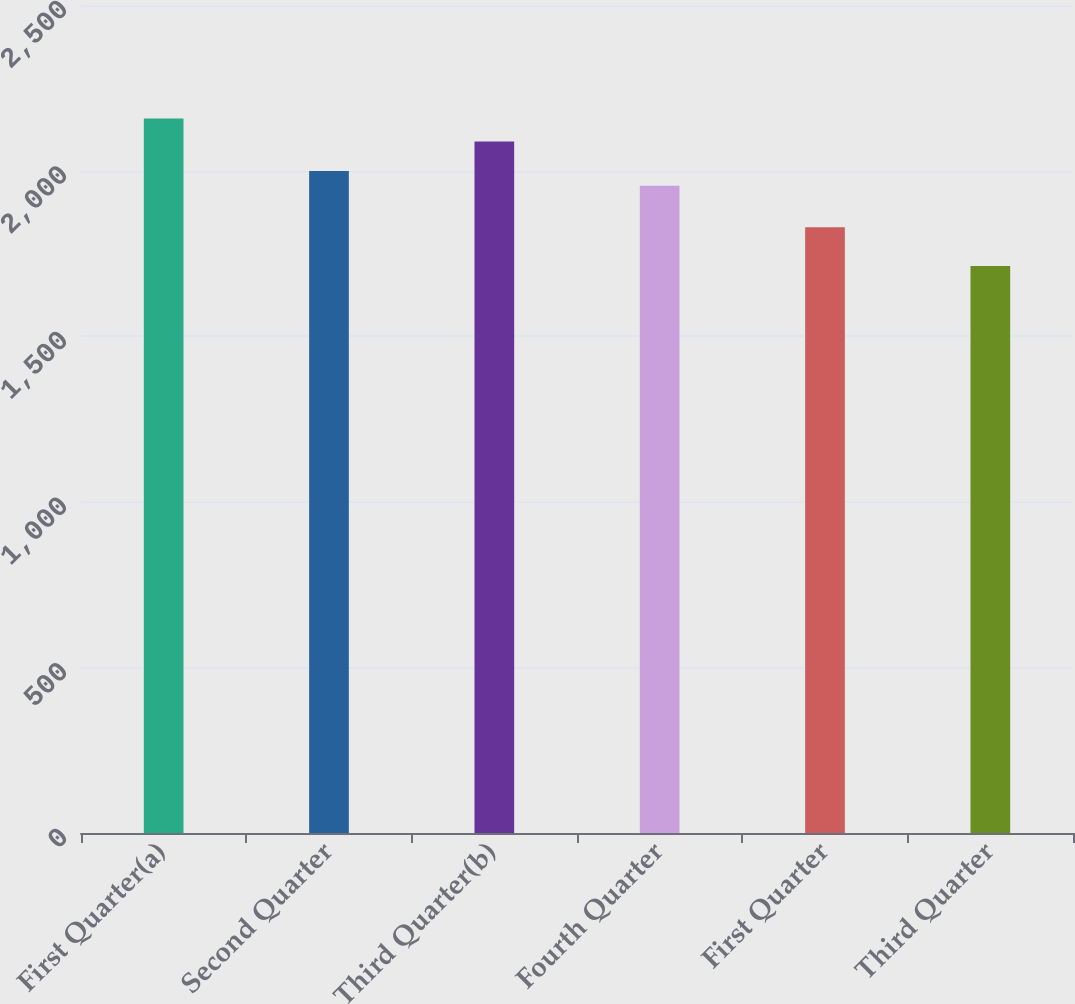<chart> <loc_0><loc_0><loc_500><loc_500><bar_chart><fcel>First Quarter(a)<fcel>Second Quarter<fcel>Third Quarter(b)<fcel>Fourth Quarter<fcel>First Quarter<fcel>Third Quarter<nl><fcel>2157.6<fcel>1998.43<fcel>2088.2<fcel>1953.9<fcel>1828.9<fcel>1712.3<nl></chart> 